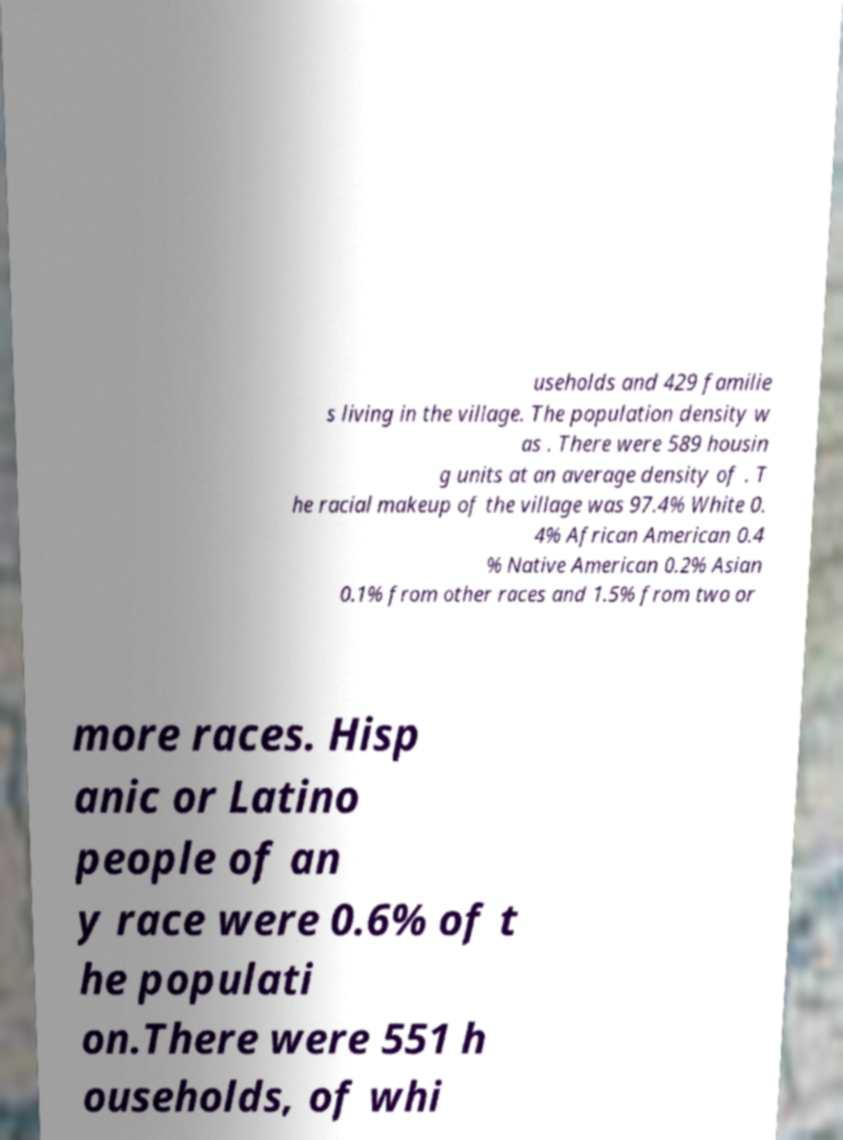Could you assist in decoding the text presented in this image and type it out clearly? useholds and 429 familie s living in the village. The population density w as . There were 589 housin g units at an average density of . T he racial makeup of the village was 97.4% White 0. 4% African American 0.4 % Native American 0.2% Asian 0.1% from other races and 1.5% from two or more races. Hisp anic or Latino people of an y race were 0.6% of t he populati on.There were 551 h ouseholds, of whi 